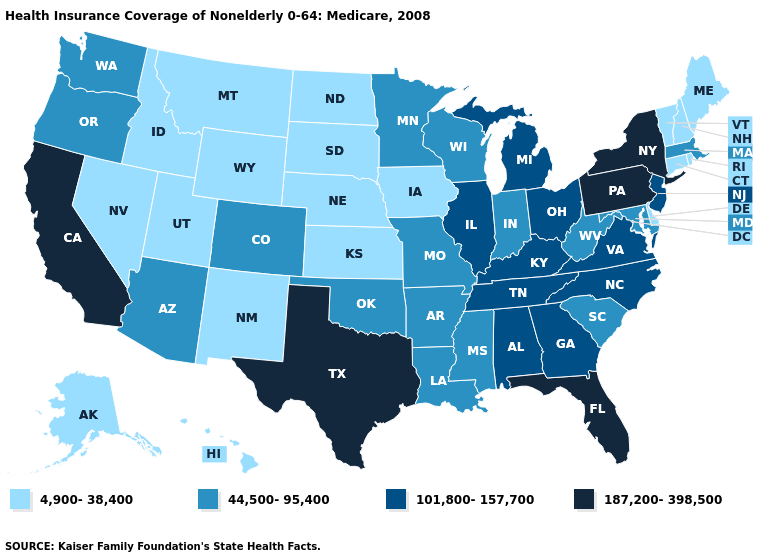Name the states that have a value in the range 187,200-398,500?
Be succinct. California, Florida, New York, Pennsylvania, Texas. What is the lowest value in the USA?
Give a very brief answer. 4,900-38,400. What is the value of Maryland?
Answer briefly. 44,500-95,400. What is the value of New Jersey?
Keep it brief. 101,800-157,700. What is the highest value in the USA?
Be succinct. 187,200-398,500. Which states have the highest value in the USA?
Give a very brief answer. California, Florida, New York, Pennsylvania, Texas. Name the states that have a value in the range 4,900-38,400?
Be succinct. Alaska, Connecticut, Delaware, Hawaii, Idaho, Iowa, Kansas, Maine, Montana, Nebraska, Nevada, New Hampshire, New Mexico, North Dakota, Rhode Island, South Dakota, Utah, Vermont, Wyoming. Among the states that border Wyoming , which have the highest value?
Short answer required. Colorado. Which states hav the highest value in the West?
Keep it brief. California. Does California have the lowest value in the West?
Concise answer only. No. Name the states that have a value in the range 101,800-157,700?
Keep it brief. Alabama, Georgia, Illinois, Kentucky, Michigan, New Jersey, North Carolina, Ohio, Tennessee, Virginia. Which states have the lowest value in the West?
Concise answer only. Alaska, Hawaii, Idaho, Montana, Nevada, New Mexico, Utah, Wyoming. Does Colorado have the highest value in the West?
Keep it brief. No. Name the states that have a value in the range 4,900-38,400?
Keep it brief. Alaska, Connecticut, Delaware, Hawaii, Idaho, Iowa, Kansas, Maine, Montana, Nebraska, Nevada, New Hampshire, New Mexico, North Dakota, Rhode Island, South Dakota, Utah, Vermont, Wyoming. 